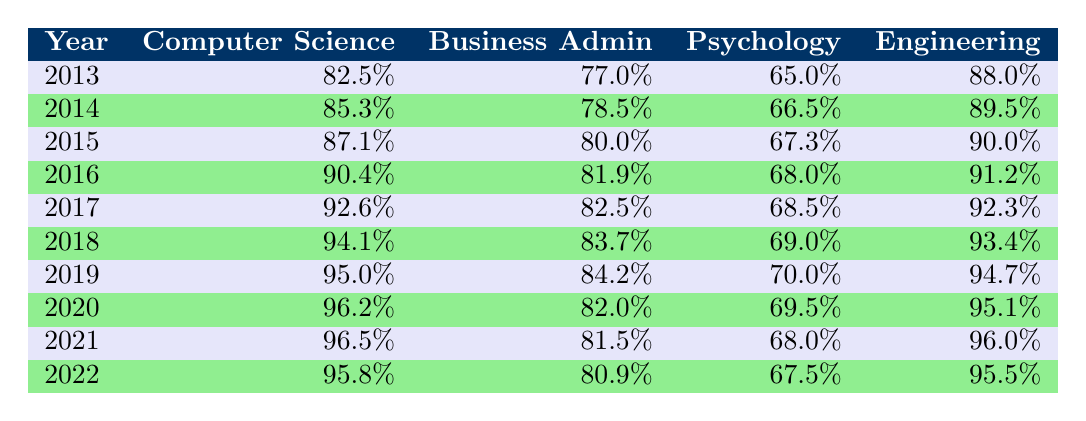What was the employment rate for graduates in Computer Science in 2020? Referring to the table, the employment rate for Computer Science in 2020 is listed as 96.2%.
Answer: 96.2% Which degree program had the lowest employment rate in 2013? Looking at the table, the employment rates for 2013 are: Computer Science - 82.5%, Business Administration - 77.0%, Psychology - 65.0%, and Engineering - 88.0%. The lowest among these is Psychology at 65.0%.
Answer: Psychology What was the average employment rate for Engineering graduates from 2013 to 2022? The employment rates for Engineering from 2013 to 2022 are: 88.0%, 89.5%, 90.0%, 91.2%, 92.3%, 93.4%, 94.7%, 95.1%, 96.0%, and 95.5%. First, we sum these rates: 88.0 + 89.5 + 90.0 + 91.2 + 92.3 + 93.4 + 94.7 + 95.1 + 96.0 + 95.5 =  919.7. There are 10 data points, so we calculate the average: 919.7 / 10 = 91.97.
Answer: 91.97 Did the employment rate for Business Administration graduates increase every year from 2013 to 2022? Checking the rates: 77.0%, 78.5%, 80.0%, 81.9%, 82.5%, 83.7%, 84.2%, 82.0%, 81.5%, and 80.9%. From this data, we can see that it decreased in 2020, 2021, and 2022. Therefore, it did not increase every year.
Answer: No What was the maximum employment rate recorded for Psychology graduates during the decade? The data for Psychology employment rates from 2013 to 2022 are: 65.0%, 66.5%, 67.3%, 68.0%, 68.5%, 69.0%, 70.0%, 69.5%, 68.0%, and 67.5%. The maximum value among these is 70.0% in 2019.
Answer: 70.0% 